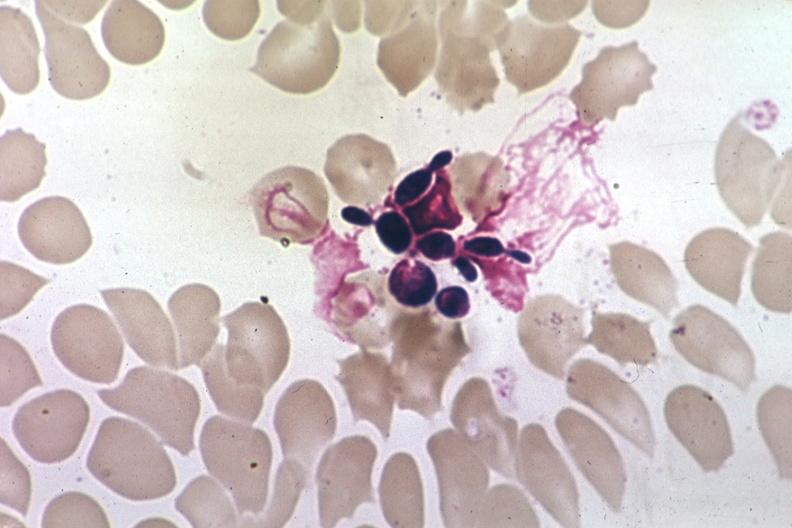what is present?
Answer the question using a single word or phrase. Hematologic 